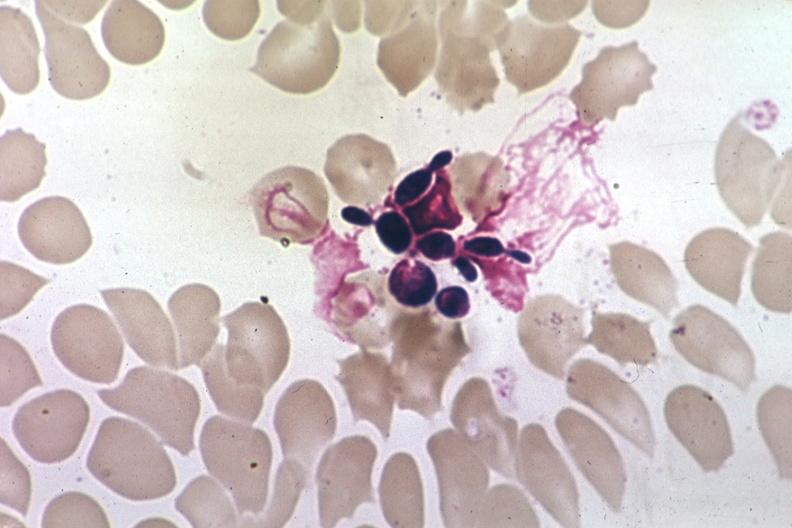what is present?
Answer the question using a single word or phrase. Hematologic 